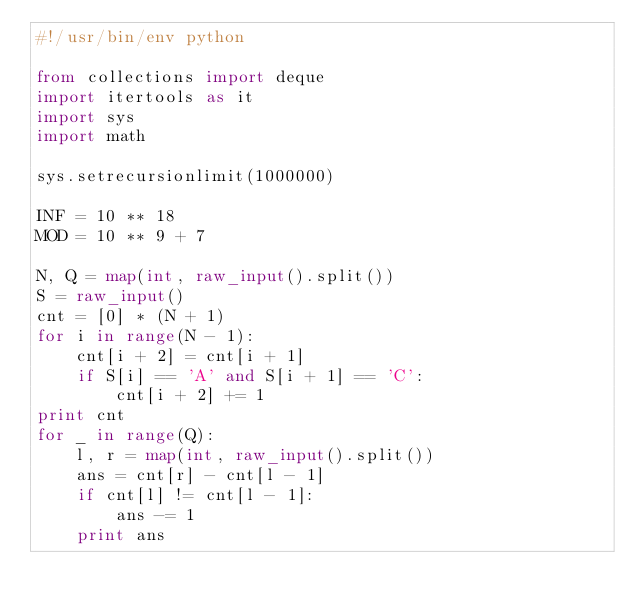Convert code to text. <code><loc_0><loc_0><loc_500><loc_500><_Python_>#!/usr/bin/env python

from collections import deque
import itertools as it
import sys
import math

sys.setrecursionlimit(1000000)

INF = 10 ** 18
MOD = 10 ** 9 + 7

N, Q = map(int, raw_input().split())
S = raw_input()
cnt = [0] * (N + 1)
for i in range(N - 1):
    cnt[i + 2] = cnt[i + 1]
    if S[i] == 'A' and S[i + 1] == 'C':
        cnt[i + 2] += 1
print cnt
for _ in range(Q):
    l, r = map(int, raw_input().split())
    ans = cnt[r] - cnt[l - 1]
    if cnt[l] != cnt[l - 1]:
        ans -= 1
    print ans</code> 